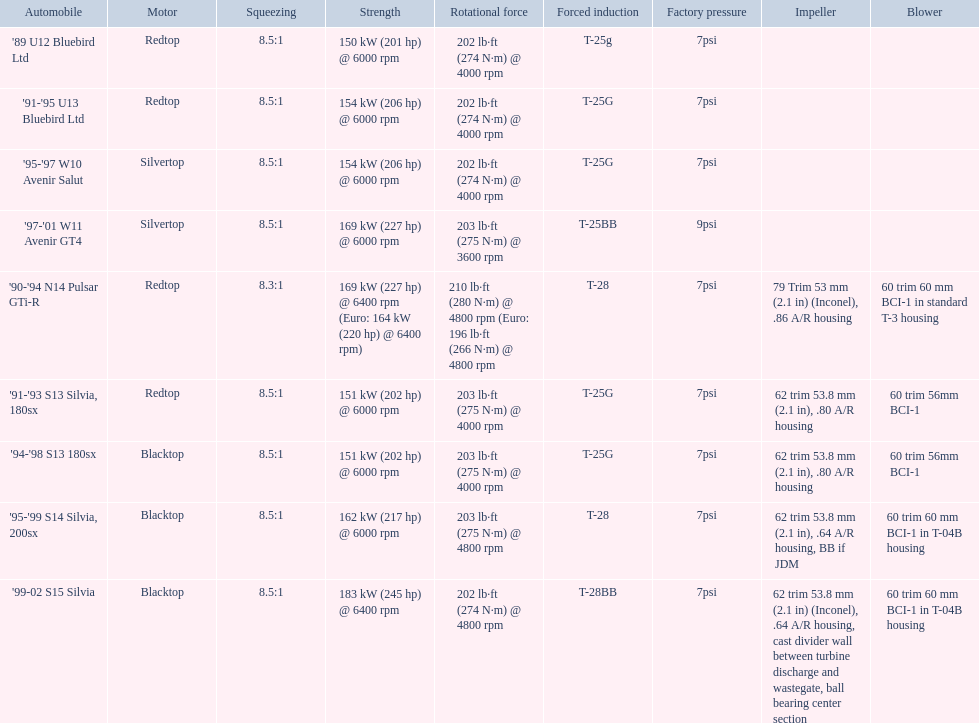How many models used the redtop engine? 4. Could you parse the entire table as a dict? {'header': ['Automobile', 'Motor', 'Squeezing', 'Strength', 'Rotational force', 'Forced induction', 'Factory pressure', 'Impeller', 'Blower'], 'rows': [["'89 U12 Bluebird Ltd", 'Redtop', '8.5:1', '150\xa0kW (201\xa0hp) @ 6000 rpm', '202\xa0lb·ft (274\xa0N·m) @ 4000 rpm', 'T-25g', '7psi', '', ''], ["'91-'95 U13 Bluebird Ltd", 'Redtop', '8.5:1', '154\xa0kW (206\xa0hp) @ 6000 rpm', '202\xa0lb·ft (274\xa0N·m) @ 4000 rpm', 'T-25G', '7psi', '', ''], ["'95-'97 W10 Avenir Salut", 'Silvertop', '8.5:1', '154\xa0kW (206\xa0hp) @ 6000 rpm', '202\xa0lb·ft (274\xa0N·m) @ 4000 rpm', 'T-25G', '7psi', '', ''], ["'97-'01 W11 Avenir GT4", 'Silvertop', '8.5:1', '169\xa0kW (227\xa0hp) @ 6000 rpm', '203\xa0lb·ft (275\xa0N·m) @ 3600 rpm', 'T-25BB', '9psi', '', ''], ["'90-'94 N14 Pulsar GTi-R", 'Redtop', '8.3:1', '169\xa0kW (227\xa0hp) @ 6400 rpm (Euro: 164\xa0kW (220\xa0hp) @ 6400 rpm)', '210\xa0lb·ft (280\xa0N·m) @ 4800 rpm (Euro: 196\xa0lb·ft (266\xa0N·m) @ 4800 rpm', 'T-28', '7psi', '79 Trim 53\xa0mm (2.1\xa0in) (Inconel), .86 A/R housing', '60 trim 60\xa0mm BCI-1 in standard T-3 housing'], ["'91-'93 S13 Silvia, 180sx", 'Redtop', '8.5:1', '151\xa0kW (202\xa0hp) @ 6000 rpm', '203\xa0lb·ft (275\xa0N·m) @ 4000 rpm', 'T-25G', '7psi', '62 trim 53.8\xa0mm (2.1\xa0in), .80 A/R housing', '60 trim 56mm BCI-1'], ["'94-'98 S13 180sx", 'Blacktop', '8.5:1', '151\xa0kW (202\xa0hp) @ 6000 rpm', '203\xa0lb·ft (275\xa0N·m) @ 4000 rpm', 'T-25G', '7psi', '62 trim 53.8\xa0mm (2.1\xa0in), .80 A/R housing', '60 trim 56mm BCI-1'], ["'95-'99 S14 Silvia, 200sx", 'Blacktop', '8.5:1', '162\xa0kW (217\xa0hp) @ 6000 rpm', '203\xa0lb·ft (275\xa0N·m) @ 4800 rpm', 'T-28', '7psi', '62 trim 53.8\xa0mm (2.1\xa0in), .64 A/R housing, BB if JDM', '60 trim 60\xa0mm BCI-1 in T-04B housing'], ["'99-02 S15 Silvia", 'Blacktop', '8.5:1', '183\xa0kW (245\xa0hp) @ 6400 rpm', '202\xa0lb·ft (274\xa0N·m) @ 4800 rpm', 'T-28BB', '7psi', '62 trim 53.8\xa0mm (2.1\xa0in) (Inconel), .64 A/R housing, cast divider wall between turbine discharge and wastegate, ball bearing center section', '60 trim 60\xa0mm BCI-1 in T-04B housing']]} 